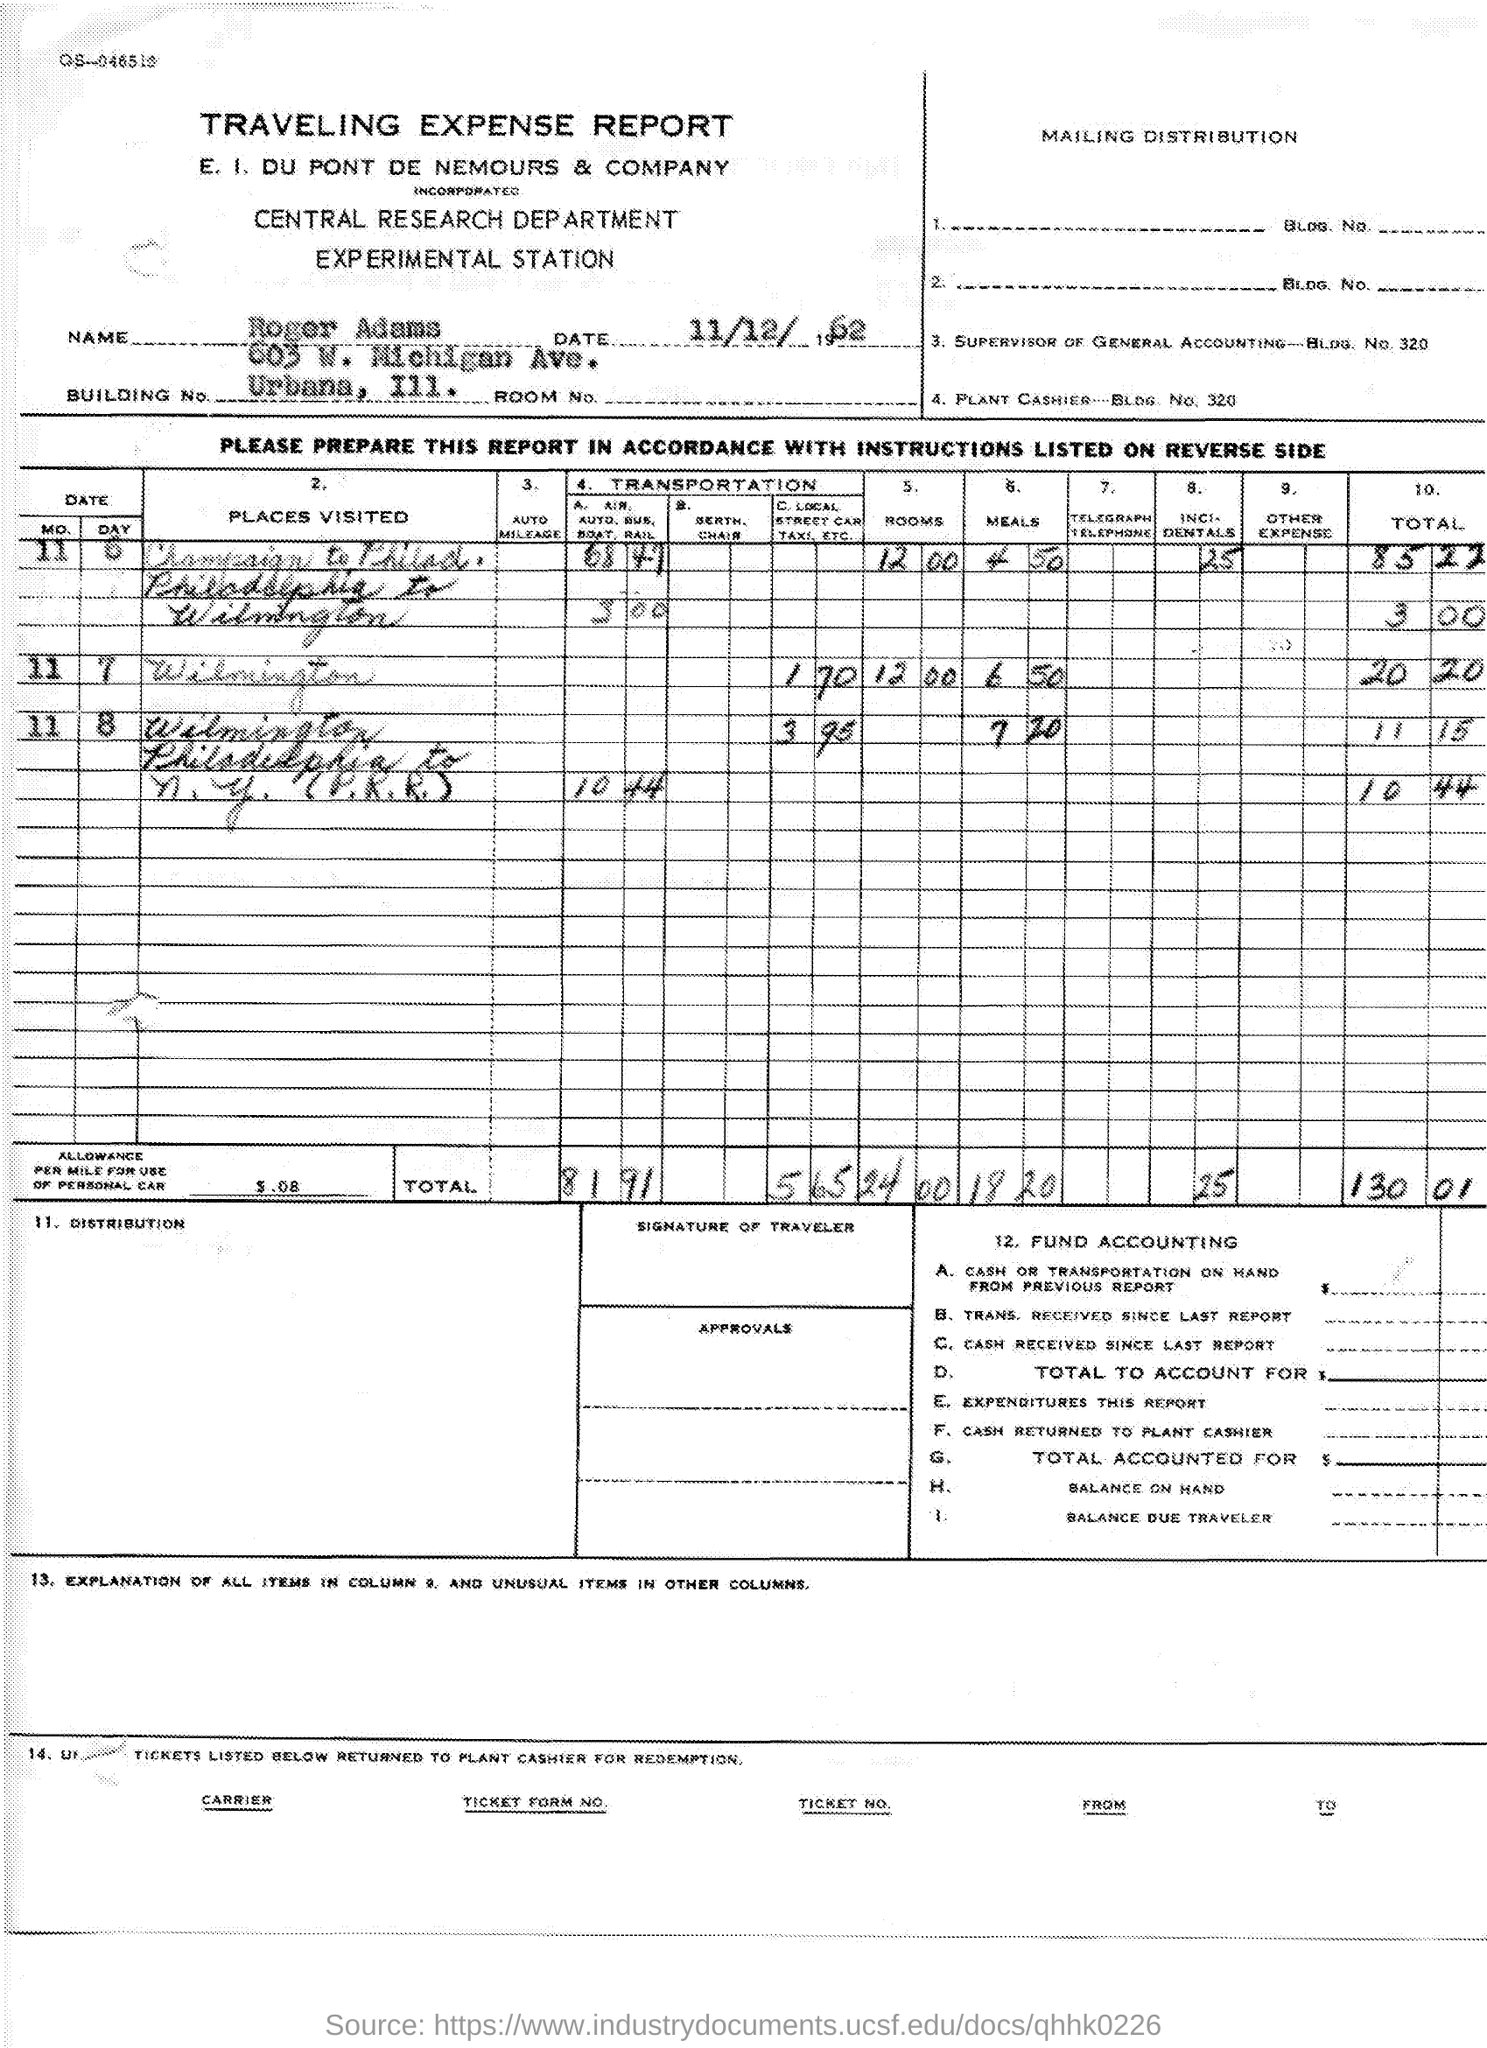What is the name mentioned in the given report ?
Offer a very short reply. Roger Adams. What is the date mentioned in the given report ?
Provide a succinct answer. 11/12/1962. What is the name of the department mentioned in the given report ?
Provide a short and direct response. CENTRAL RESEARCH DEPARTMENT. 